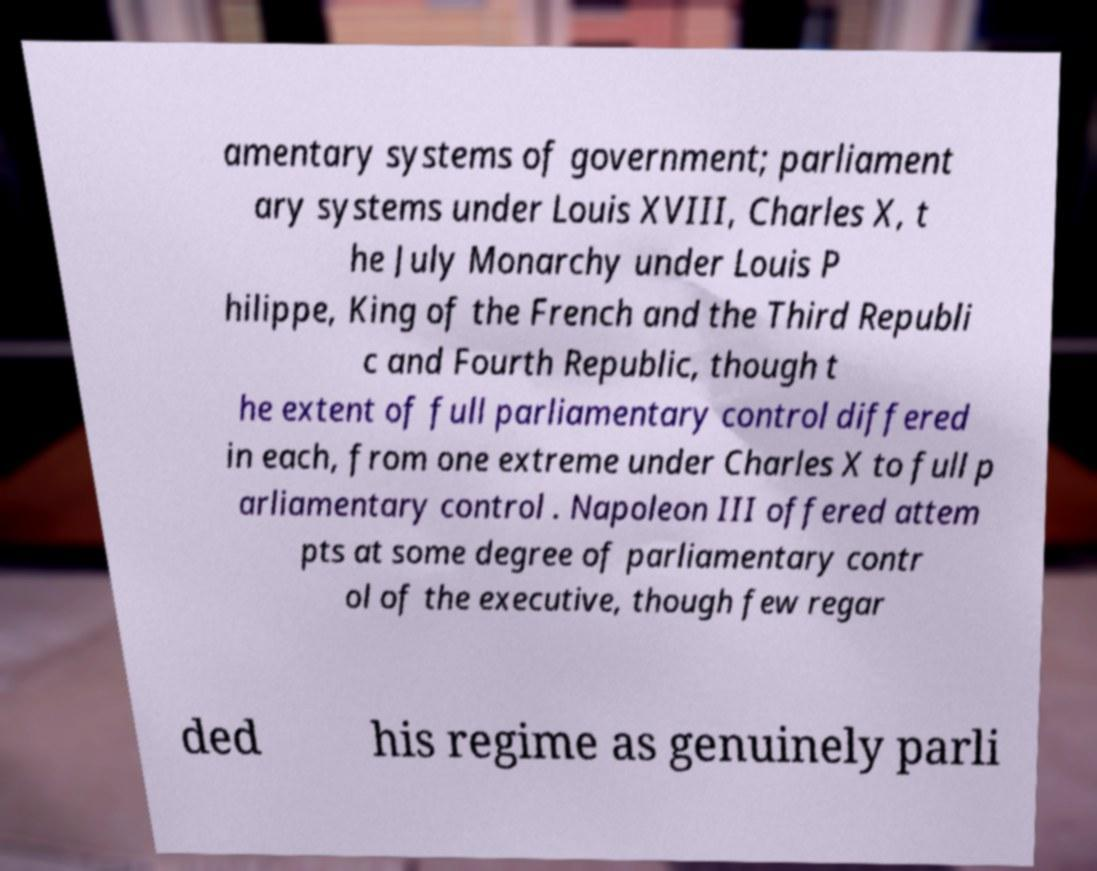Can you accurately transcribe the text from the provided image for me? amentary systems of government; parliament ary systems under Louis XVIII, Charles X, t he July Monarchy under Louis P hilippe, King of the French and the Third Republi c and Fourth Republic, though t he extent of full parliamentary control differed in each, from one extreme under Charles X to full p arliamentary control . Napoleon III offered attem pts at some degree of parliamentary contr ol of the executive, though few regar ded his regime as genuinely parli 